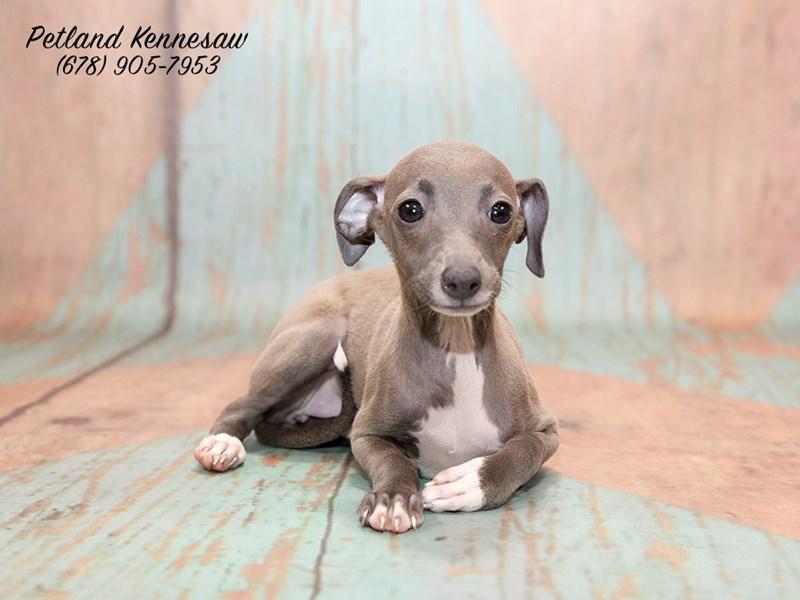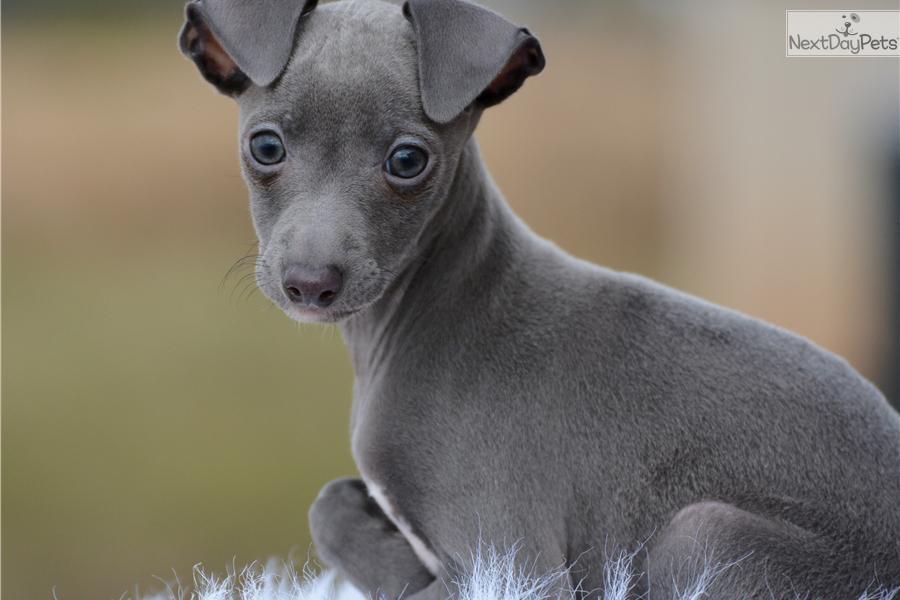The first image is the image on the left, the second image is the image on the right. Given the left and right images, does the statement "Two dogs are looking straight ahead." hold true? Answer yes or no. Yes. 